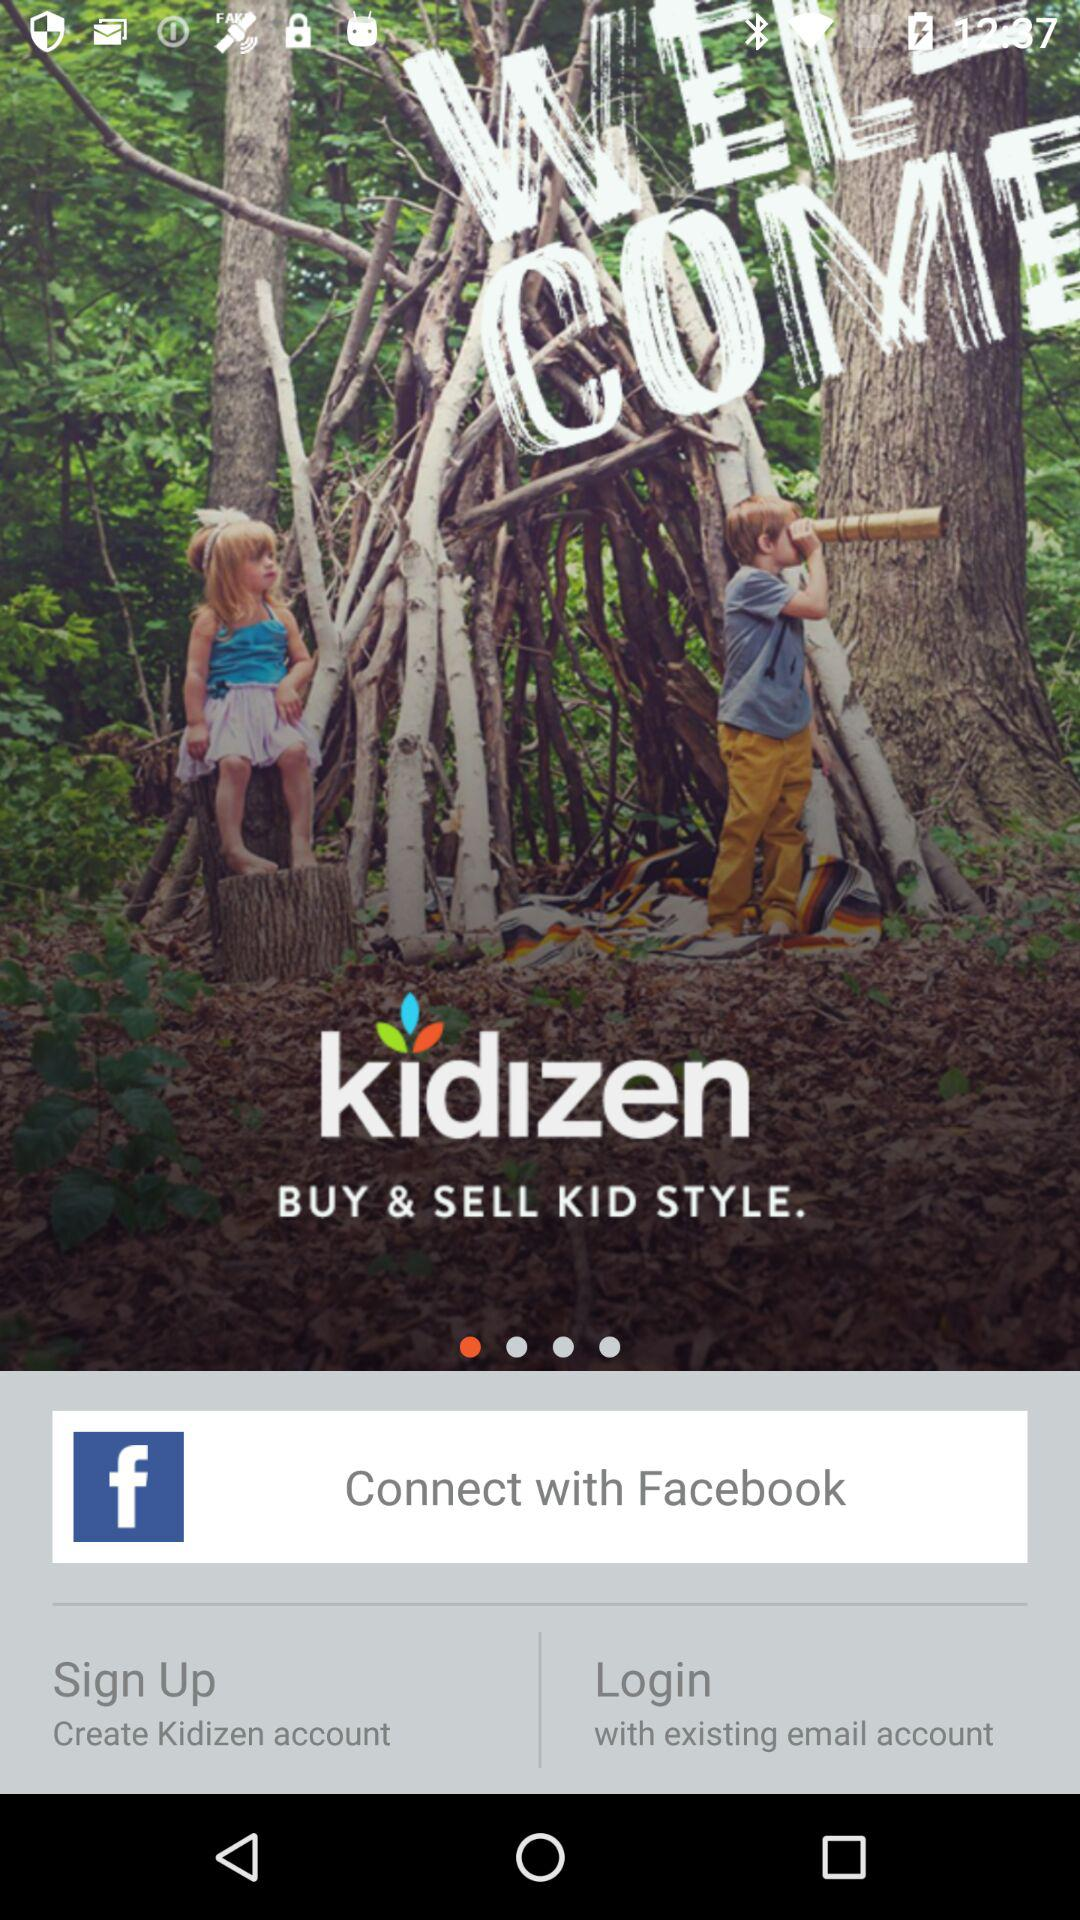What is the other login option? The other login option is "email". 